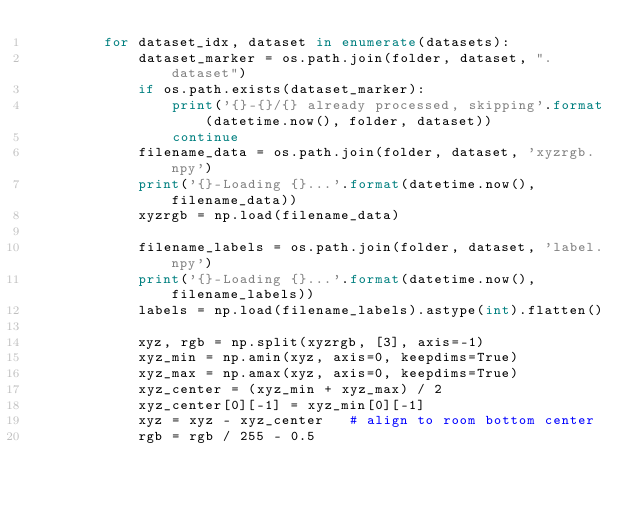<code> <loc_0><loc_0><loc_500><loc_500><_Python_>        for dataset_idx, dataset in enumerate(datasets):
            dataset_marker = os.path.join(folder, dataset, ".dataset")
            if os.path.exists(dataset_marker):
                print('{}-{}/{} already processed, skipping'.format(datetime.now(), folder, dataset))
                continue
            filename_data = os.path.join(folder, dataset, 'xyzrgb.npy')
            print('{}-Loading {}...'.format(datetime.now(), filename_data))
            xyzrgb = np.load(filename_data)

            filename_labels = os.path.join(folder, dataset, 'label.npy')
            print('{}-Loading {}...'.format(datetime.now(), filename_labels))
            labels = np.load(filename_labels).astype(int).flatten()

            xyz, rgb = np.split(xyzrgb, [3], axis=-1)
            xyz_min = np.amin(xyz, axis=0, keepdims=True)
            xyz_max = np.amax(xyz, axis=0, keepdims=True)
            xyz_center = (xyz_min + xyz_max) / 2
            xyz_center[0][-1] = xyz_min[0][-1]
            xyz = xyz - xyz_center   # align to room bottom center
            rgb = rgb / 255 - 0.5
</code> 